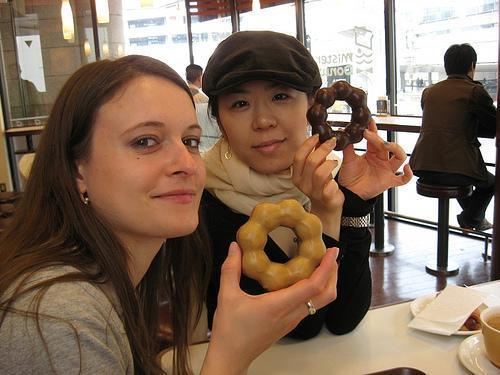How many people can you see?
Give a very brief answer. 3. How many donuts can you see?
Give a very brief answer. 2. 